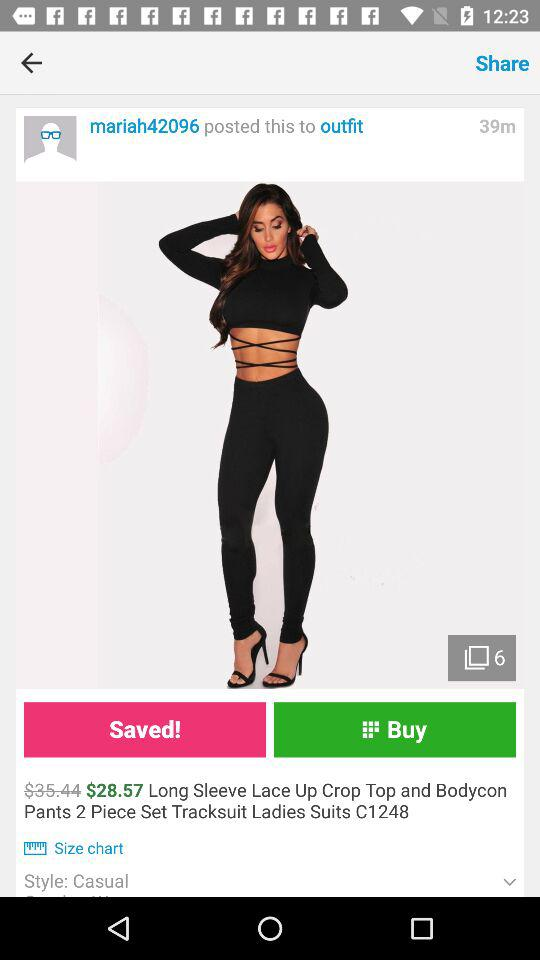What is the discounted price of the product? The discounted price of the product is $28.57. 